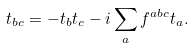Convert formula to latex. <formula><loc_0><loc_0><loc_500><loc_500>t _ { b c } = - t _ { b } t _ { c } - i \sum _ { a } f ^ { a b c } t _ { a } .</formula> 